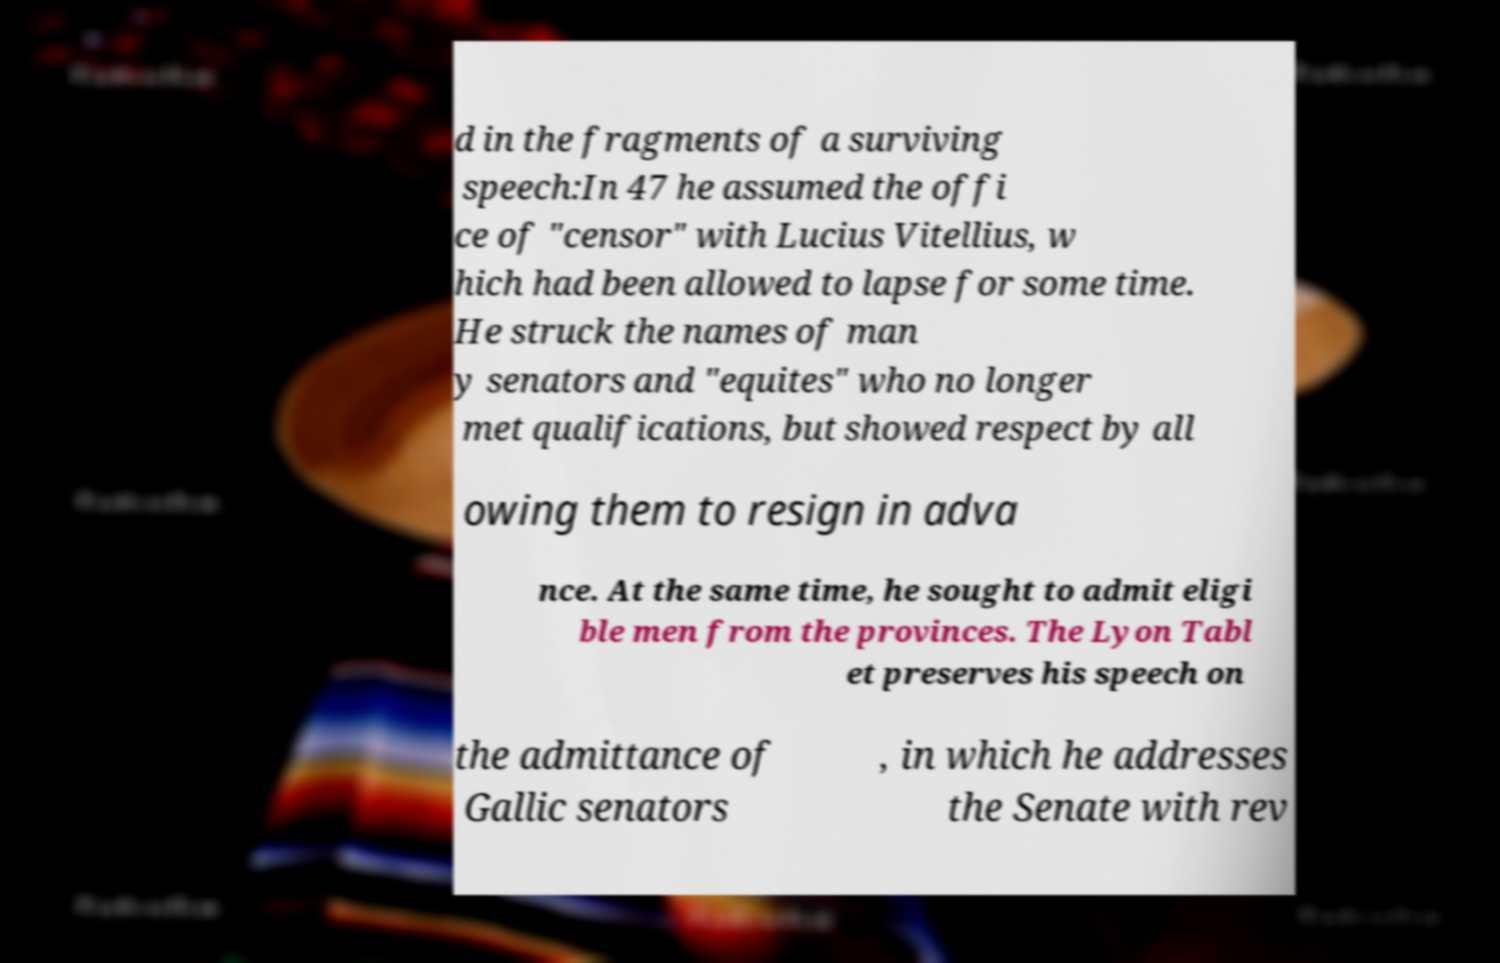Could you extract and type out the text from this image? d in the fragments of a surviving speech:In 47 he assumed the offi ce of "censor" with Lucius Vitellius, w hich had been allowed to lapse for some time. He struck the names of man y senators and "equites" who no longer met qualifications, but showed respect by all owing them to resign in adva nce. At the same time, he sought to admit eligi ble men from the provinces. The Lyon Tabl et preserves his speech on the admittance of Gallic senators , in which he addresses the Senate with rev 